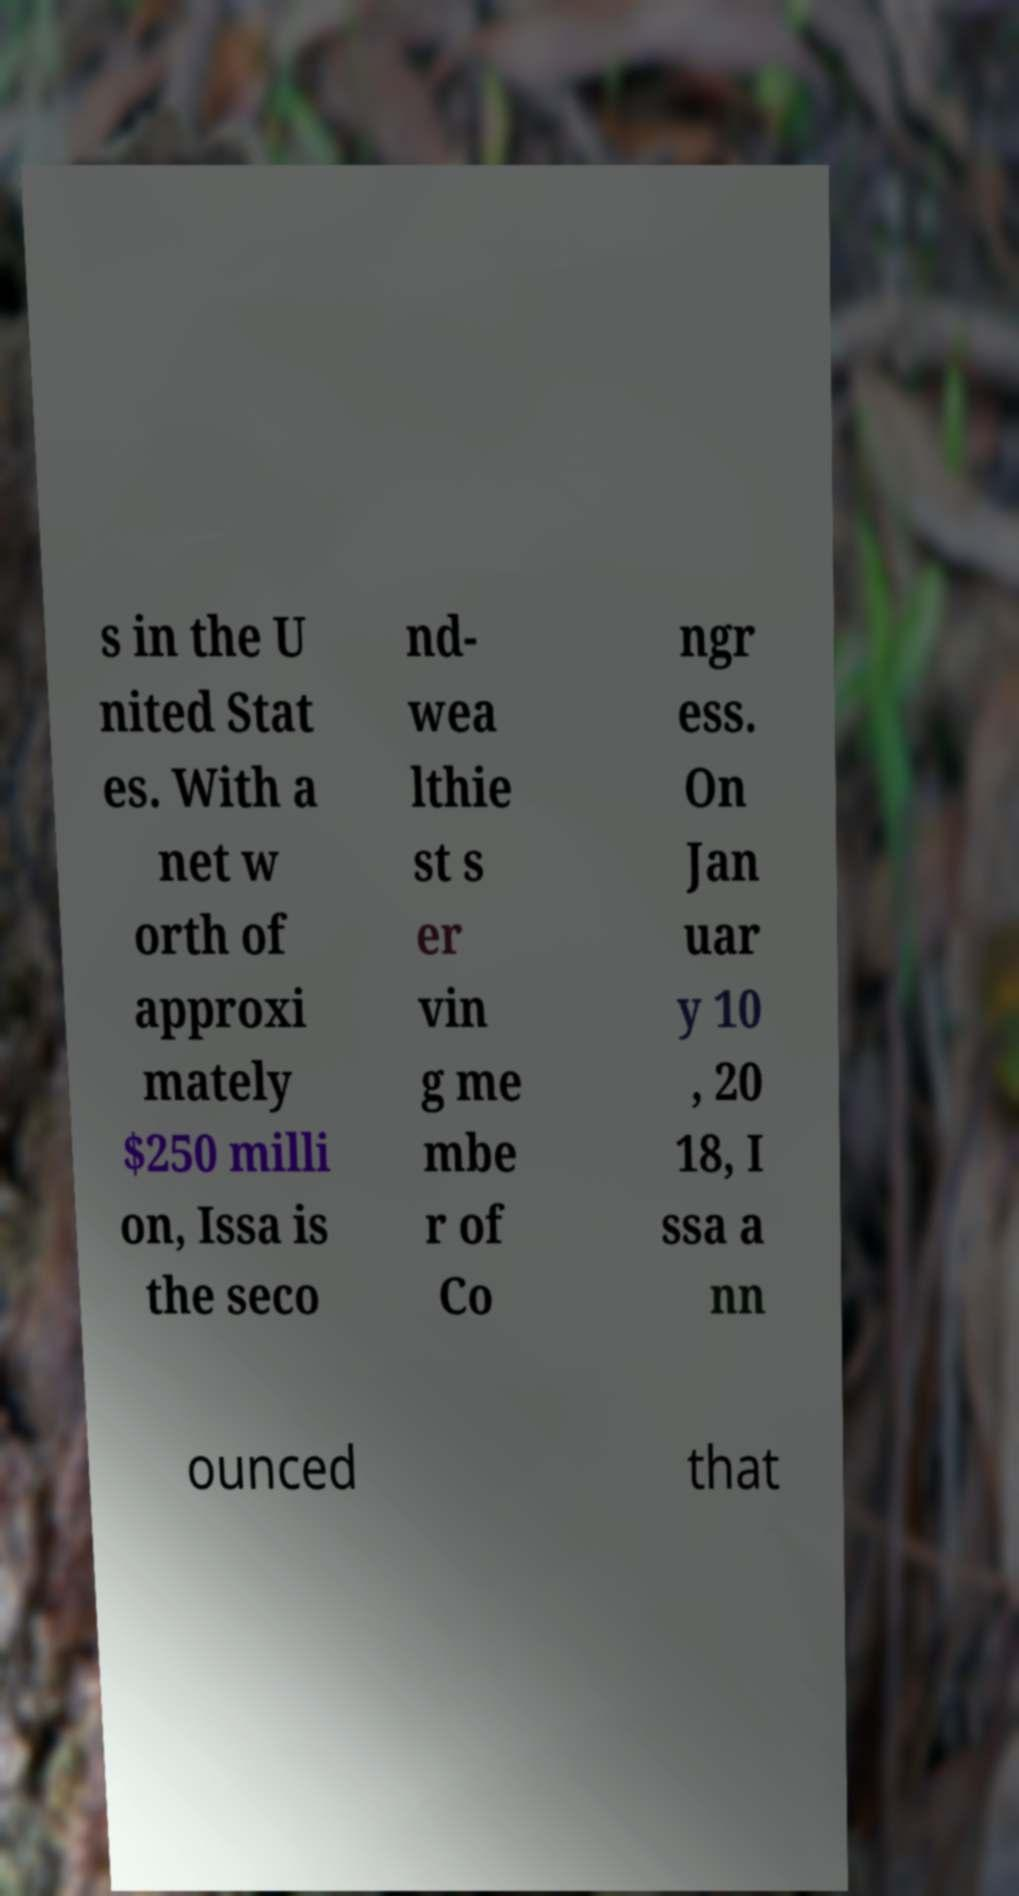Please read and relay the text visible in this image. What does it say? s in the U nited Stat es. With a net w orth of approxi mately $250 milli on, Issa is the seco nd- wea lthie st s er vin g me mbe r of Co ngr ess. On Jan uar y 10 , 20 18, I ssa a nn ounced that 